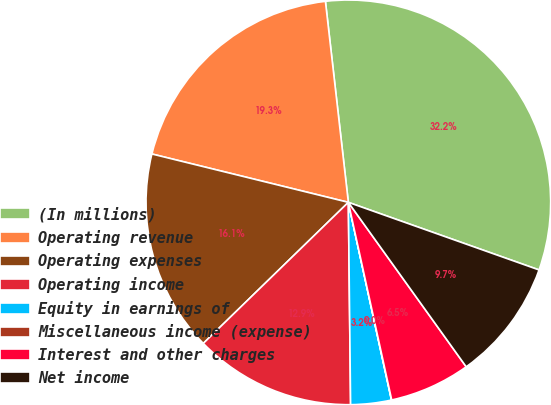Convert chart to OTSL. <chart><loc_0><loc_0><loc_500><loc_500><pie_chart><fcel>(In millions)<fcel>Operating revenue<fcel>Operating expenses<fcel>Operating income<fcel>Equity in earnings of<fcel>Miscellaneous income (expense)<fcel>Interest and other charges<fcel>Net income<nl><fcel>32.23%<fcel>19.35%<fcel>16.12%<fcel>12.9%<fcel>3.24%<fcel>0.02%<fcel>6.46%<fcel>9.68%<nl></chart> 